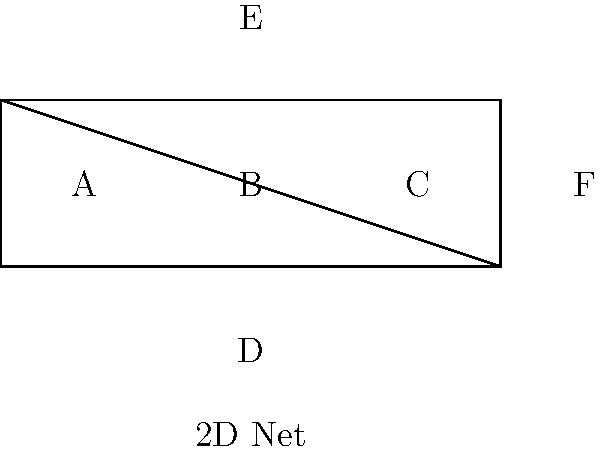As a psychologist working with patients who have spatial perception difficulties, you're developing a test to assess their ability to visualize 3D objects. Given the 2D net shown above, which 3D shape would it form when folded along the edges? Consider how this task might challenge patients with certain mental health conditions.

A) Cube
B) Rectangular Prism
C) Triangular Prism
D) Tetrahedron To determine the 3D shape formed by this net, let's analyze it step-by-step:

1. Count the faces: The net has 6 rectangular faces (A, B, C, D, E, and F).

2. Analyze the arrangement:
   - Four rectangles (A, B, C, F) are arranged in a line.
   - Two additional rectangles (D, E) are attached to the middle two rectangles.

3. Visualize the folding process:
   - Rectangles A, B, C, and F would form four sides of a box.
   - Rectangle D would fold up to form the bottom.
   - Rectangle E would fold down to form the top.

4. Consider the shape characteristics:
   - All faces are rectangles.
   - When folded, it will have 6 rectangular faces.
   - Opposite faces are parallel.

5. Identify the 3D shape:
   - A shape with 6 rectangular faces is a rectangular prism.
   - If all faces were squares, it would be a cube, but they're not necessarily equal.

6. Relate to mental health:
   - Patients with conditions affecting spatial perception (e.g., some forms of schizophrenia or neurological disorders) might struggle with this visualization task.
   - This exercise could help assess the severity of their condition and track progress in treatment.

Therefore, the 2D net would form a rectangular prism when folded.
Answer: Rectangular Prism 